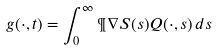Convert formula to latex. <formula><loc_0><loc_0><loc_500><loc_500>g ( \cdot , t ) = \int _ { 0 } ^ { \infty } \P \nabla S ( s ) Q ( \cdot , s ) \, d s</formula> 